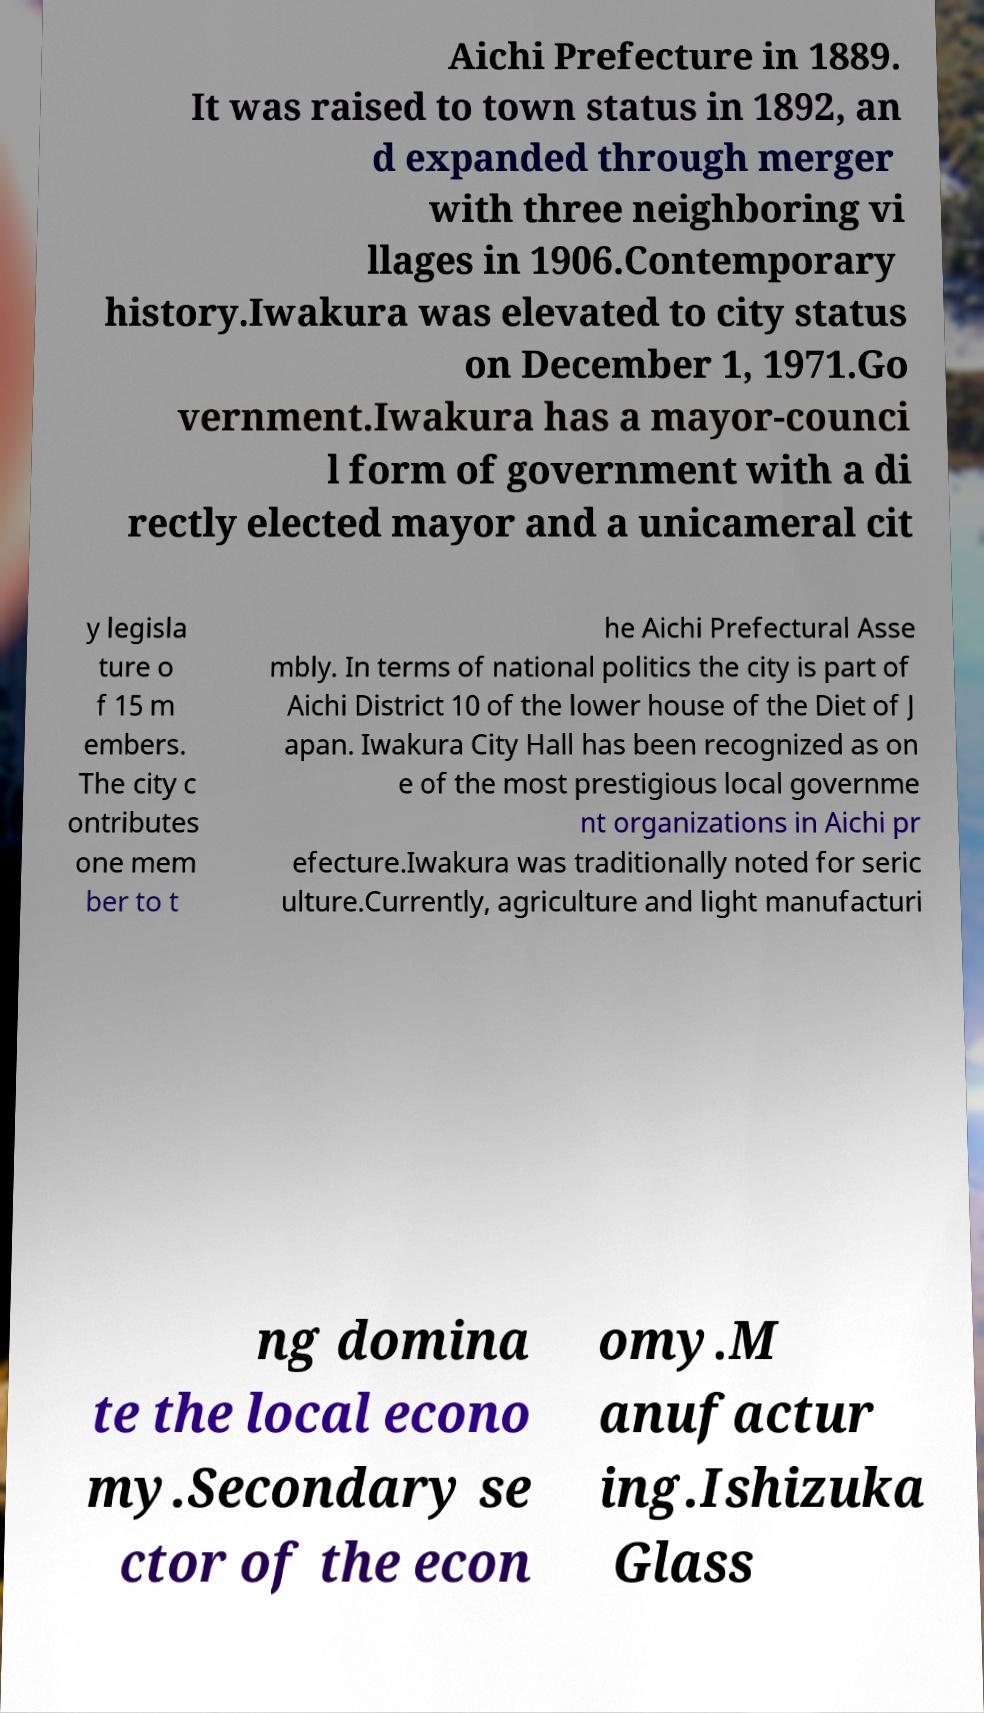Please identify and transcribe the text found in this image. Aichi Prefecture in 1889. It was raised to town status in 1892, an d expanded through merger with three neighboring vi llages in 1906.Contemporary history.Iwakura was elevated to city status on December 1, 1971.Go vernment.Iwakura has a mayor-counci l form of government with a di rectly elected mayor and a unicameral cit y legisla ture o f 15 m embers. The city c ontributes one mem ber to t he Aichi Prefectural Asse mbly. In terms of national politics the city is part of Aichi District 10 of the lower house of the Diet of J apan. Iwakura City Hall has been recognized as on e of the most prestigious local governme nt organizations in Aichi pr efecture.Iwakura was traditionally noted for seric ulture.Currently, agriculture and light manufacturi ng domina te the local econo my.Secondary se ctor of the econ omy.M anufactur ing.Ishizuka Glass 